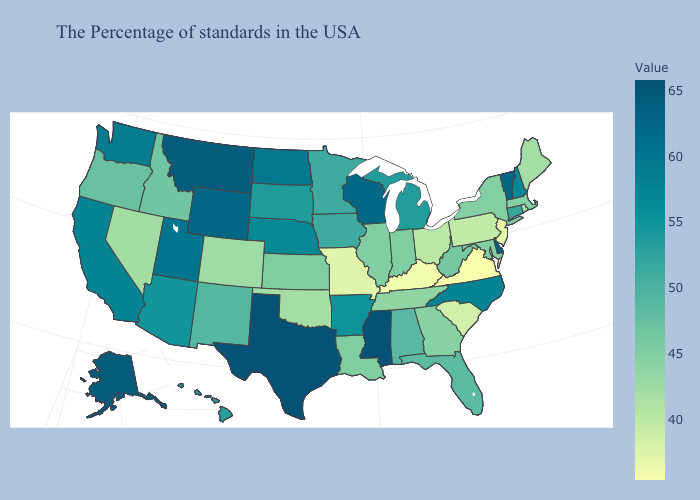Does Maryland have the lowest value in the USA?
Give a very brief answer. No. Among the states that border Tennessee , which have the lowest value?
Give a very brief answer. Virginia. Does the map have missing data?
Give a very brief answer. No. 